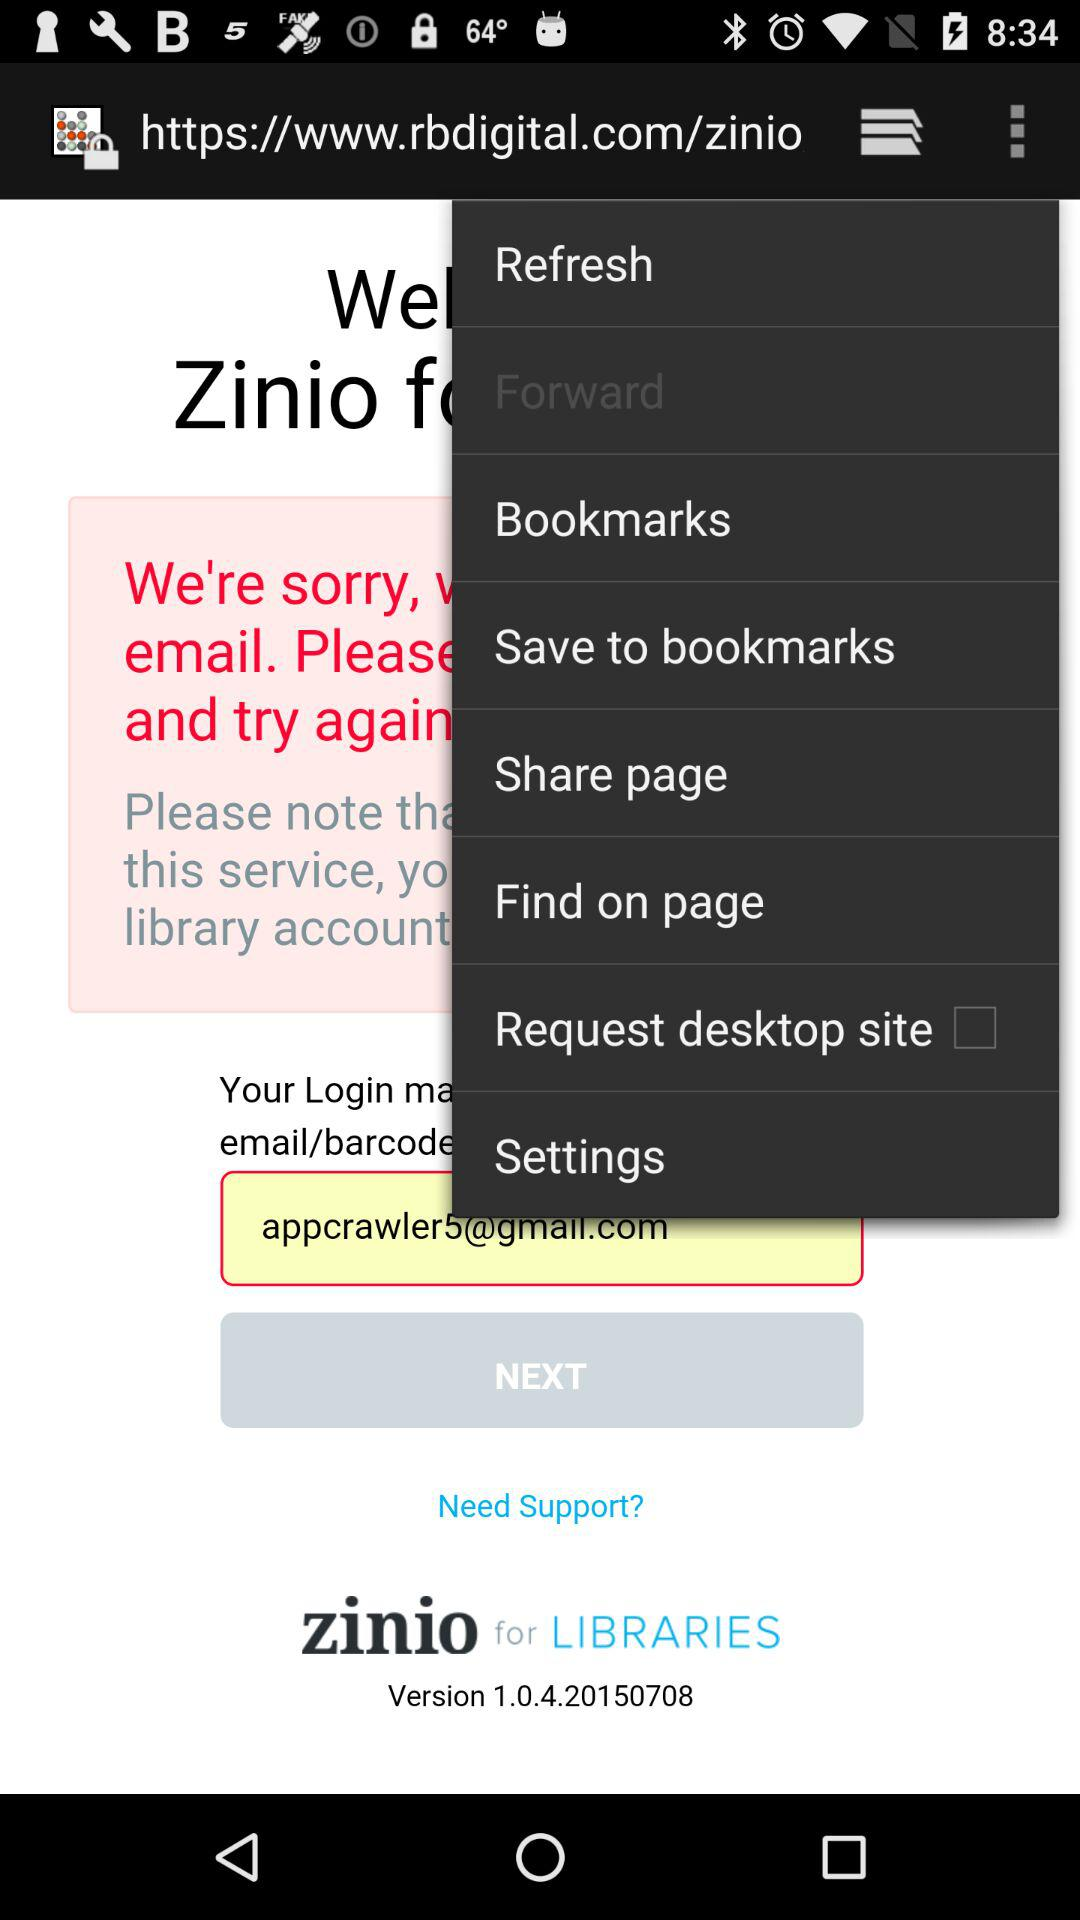What is the name of the application? The name of the application is "zinio". 